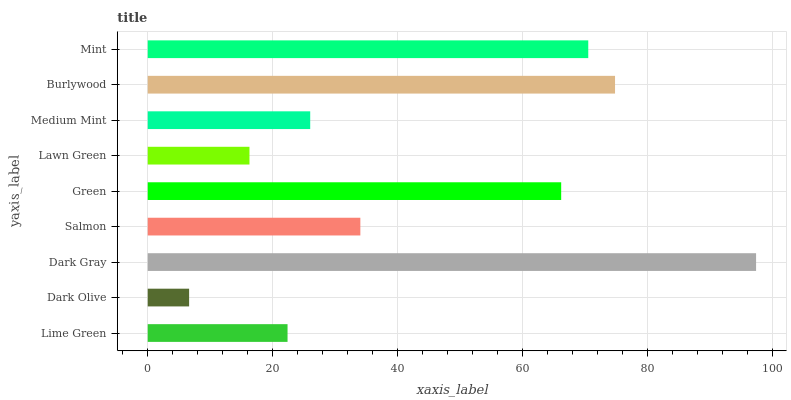Is Dark Olive the minimum?
Answer yes or no. Yes. Is Dark Gray the maximum?
Answer yes or no. Yes. Is Dark Gray the minimum?
Answer yes or no. No. Is Dark Olive the maximum?
Answer yes or no. No. Is Dark Gray greater than Dark Olive?
Answer yes or no. Yes. Is Dark Olive less than Dark Gray?
Answer yes or no. Yes. Is Dark Olive greater than Dark Gray?
Answer yes or no. No. Is Dark Gray less than Dark Olive?
Answer yes or no. No. Is Salmon the high median?
Answer yes or no. Yes. Is Salmon the low median?
Answer yes or no. Yes. Is Dark Olive the high median?
Answer yes or no. No. Is Mint the low median?
Answer yes or no. No. 